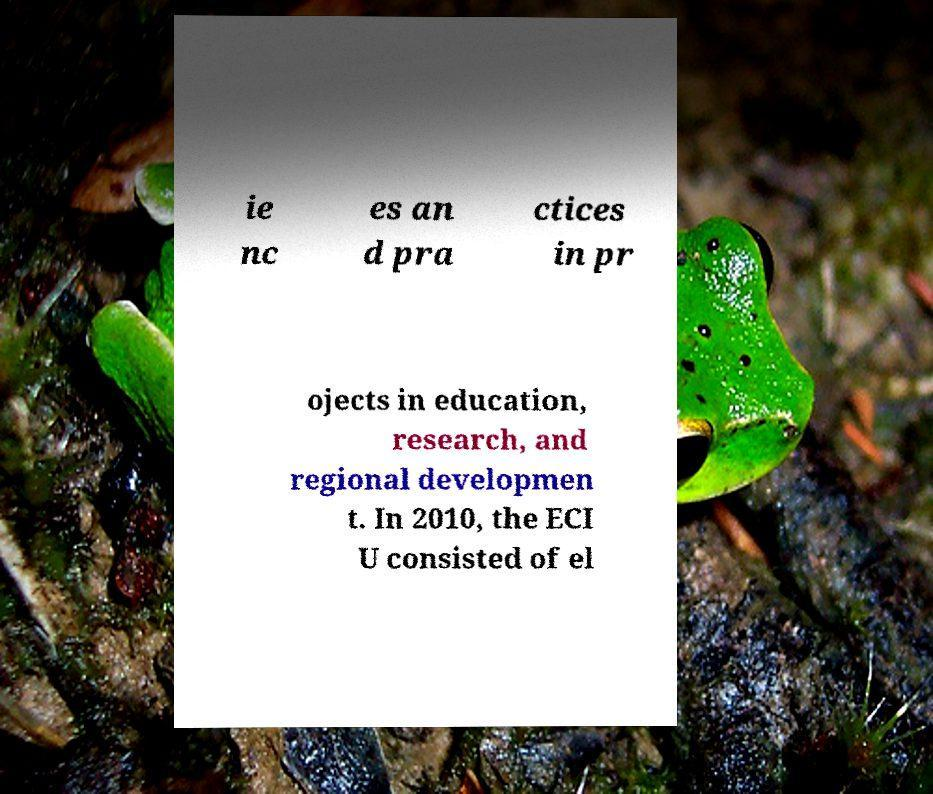What messages or text are displayed in this image? I need them in a readable, typed format. ie nc es an d pra ctices in pr ojects in education, research, and regional developmen t. In 2010, the ECI U consisted of el 